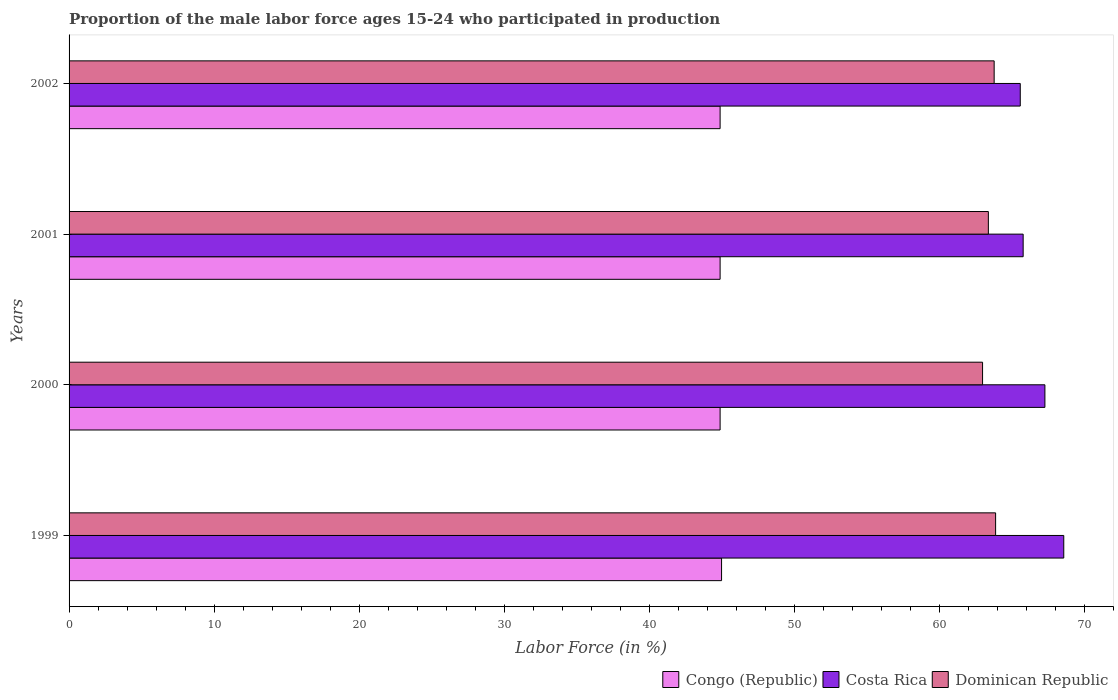How many different coloured bars are there?
Your response must be concise. 3. Are the number of bars per tick equal to the number of legend labels?
Offer a very short reply. Yes. Are the number of bars on each tick of the Y-axis equal?
Your answer should be very brief. Yes. How many bars are there on the 1st tick from the top?
Give a very brief answer. 3. What is the label of the 1st group of bars from the top?
Ensure brevity in your answer.  2002. Across all years, what is the maximum proportion of the male labor force who participated in production in Costa Rica?
Make the answer very short. 68.6. Across all years, what is the minimum proportion of the male labor force who participated in production in Dominican Republic?
Ensure brevity in your answer.  63. In which year was the proportion of the male labor force who participated in production in Costa Rica maximum?
Your answer should be very brief. 1999. What is the total proportion of the male labor force who participated in production in Dominican Republic in the graph?
Your answer should be compact. 254.1. What is the difference between the proportion of the male labor force who participated in production in Congo (Republic) in 1999 and that in 2000?
Your response must be concise. 0.1. What is the difference between the proportion of the male labor force who participated in production in Congo (Republic) in 1999 and the proportion of the male labor force who participated in production in Dominican Republic in 2002?
Ensure brevity in your answer.  -18.8. What is the average proportion of the male labor force who participated in production in Dominican Republic per year?
Provide a short and direct response. 63.53. In the year 2001, what is the difference between the proportion of the male labor force who participated in production in Costa Rica and proportion of the male labor force who participated in production in Dominican Republic?
Provide a succinct answer. 2.4. What is the ratio of the proportion of the male labor force who participated in production in Dominican Republic in 1999 to that in 2000?
Offer a terse response. 1.01. Is the proportion of the male labor force who participated in production in Congo (Republic) in 1999 less than that in 2002?
Offer a very short reply. No. What is the difference between the highest and the second highest proportion of the male labor force who participated in production in Dominican Republic?
Your response must be concise. 0.1. What is the difference between the highest and the lowest proportion of the male labor force who participated in production in Dominican Republic?
Give a very brief answer. 0.9. In how many years, is the proportion of the male labor force who participated in production in Dominican Republic greater than the average proportion of the male labor force who participated in production in Dominican Republic taken over all years?
Provide a succinct answer. 2. Is the sum of the proportion of the male labor force who participated in production in Dominican Republic in 2001 and 2002 greater than the maximum proportion of the male labor force who participated in production in Costa Rica across all years?
Provide a short and direct response. Yes. What does the 2nd bar from the bottom in 2001 represents?
Provide a short and direct response. Costa Rica. Is it the case that in every year, the sum of the proportion of the male labor force who participated in production in Dominican Republic and proportion of the male labor force who participated in production in Congo (Republic) is greater than the proportion of the male labor force who participated in production in Costa Rica?
Your answer should be compact. Yes. How many bars are there?
Offer a terse response. 12. Are the values on the major ticks of X-axis written in scientific E-notation?
Offer a terse response. No. Does the graph contain grids?
Your answer should be compact. No. Where does the legend appear in the graph?
Keep it short and to the point. Bottom right. How many legend labels are there?
Keep it short and to the point. 3. What is the title of the graph?
Ensure brevity in your answer.  Proportion of the male labor force ages 15-24 who participated in production. Does "Hong Kong" appear as one of the legend labels in the graph?
Provide a short and direct response. No. What is the Labor Force (in %) of Costa Rica in 1999?
Provide a short and direct response. 68.6. What is the Labor Force (in %) of Dominican Republic in 1999?
Provide a short and direct response. 63.9. What is the Labor Force (in %) of Congo (Republic) in 2000?
Provide a short and direct response. 44.9. What is the Labor Force (in %) of Costa Rica in 2000?
Your response must be concise. 67.3. What is the Labor Force (in %) of Congo (Republic) in 2001?
Provide a succinct answer. 44.9. What is the Labor Force (in %) of Costa Rica in 2001?
Ensure brevity in your answer.  65.8. What is the Labor Force (in %) of Dominican Republic in 2001?
Make the answer very short. 63.4. What is the Labor Force (in %) in Congo (Republic) in 2002?
Your response must be concise. 44.9. What is the Labor Force (in %) of Costa Rica in 2002?
Keep it short and to the point. 65.6. What is the Labor Force (in %) in Dominican Republic in 2002?
Provide a succinct answer. 63.8. Across all years, what is the maximum Labor Force (in %) of Costa Rica?
Give a very brief answer. 68.6. Across all years, what is the maximum Labor Force (in %) of Dominican Republic?
Make the answer very short. 63.9. Across all years, what is the minimum Labor Force (in %) in Congo (Republic)?
Keep it short and to the point. 44.9. Across all years, what is the minimum Labor Force (in %) of Costa Rica?
Make the answer very short. 65.6. Across all years, what is the minimum Labor Force (in %) in Dominican Republic?
Make the answer very short. 63. What is the total Labor Force (in %) of Congo (Republic) in the graph?
Your response must be concise. 179.7. What is the total Labor Force (in %) in Costa Rica in the graph?
Offer a very short reply. 267.3. What is the total Labor Force (in %) in Dominican Republic in the graph?
Provide a short and direct response. 254.1. What is the difference between the Labor Force (in %) of Congo (Republic) in 1999 and that in 2000?
Your answer should be compact. 0.1. What is the difference between the Labor Force (in %) in Dominican Republic in 1999 and that in 2000?
Keep it short and to the point. 0.9. What is the difference between the Labor Force (in %) of Dominican Republic in 1999 and that in 2001?
Offer a very short reply. 0.5. What is the difference between the Labor Force (in %) of Congo (Republic) in 2000 and that in 2001?
Provide a succinct answer. 0. What is the difference between the Labor Force (in %) in Costa Rica in 2000 and that in 2002?
Offer a very short reply. 1.7. What is the difference between the Labor Force (in %) in Dominican Republic in 2000 and that in 2002?
Offer a terse response. -0.8. What is the difference between the Labor Force (in %) of Costa Rica in 2001 and that in 2002?
Your answer should be very brief. 0.2. What is the difference between the Labor Force (in %) in Dominican Republic in 2001 and that in 2002?
Your answer should be very brief. -0.4. What is the difference between the Labor Force (in %) of Congo (Republic) in 1999 and the Labor Force (in %) of Costa Rica in 2000?
Provide a succinct answer. -22.3. What is the difference between the Labor Force (in %) of Costa Rica in 1999 and the Labor Force (in %) of Dominican Republic in 2000?
Offer a terse response. 5.6. What is the difference between the Labor Force (in %) in Congo (Republic) in 1999 and the Labor Force (in %) in Costa Rica in 2001?
Provide a short and direct response. -20.8. What is the difference between the Labor Force (in %) in Congo (Republic) in 1999 and the Labor Force (in %) in Dominican Republic in 2001?
Provide a short and direct response. -18.4. What is the difference between the Labor Force (in %) in Congo (Republic) in 1999 and the Labor Force (in %) in Costa Rica in 2002?
Make the answer very short. -20.6. What is the difference between the Labor Force (in %) in Congo (Republic) in 1999 and the Labor Force (in %) in Dominican Republic in 2002?
Provide a short and direct response. -18.8. What is the difference between the Labor Force (in %) of Congo (Republic) in 2000 and the Labor Force (in %) of Costa Rica in 2001?
Your answer should be very brief. -20.9. What is the difference between the Labor Force (in %) in Congo (Republic) in 2000 and the Labor Force (in %) in Dominican Republic in 2001?
Provide a short and direct response. -18.5. What is the difference between the Labor Force (in %) of Congo (Republic) in 2000 and the Labor Force (in %) of Costa Rica in 2002?
Your answer should be very brief. -20.7. What is the difference between the Labor Force (in %) in Congo (Republic) in 2000 and the Labor Force (in %) in Dominican Republic in 2002?
Offer a very short reply. -18.9. What is the difference between the Labor Force (in %) in Congo (Republic) in 2001 and the Labor Force (in %) in Costa Rica in 2002?
Make the answer very short. -20.7. What is the difference between the Labor Force (in %) of Congo (Republic) in 2001 and the Labor Force (in %) of Dominican Republic in 2002?
Offer a very short reply. -18.9. What is the difference between the Labor Force (in %) in Costa Rica in 2001 and the Labor Force (in %) in Dominican Republic in 2002?
Make the answer very short. 2. What is the average Labor Force (in %) of Congo (Republic) per year?
Ensure brevity in your answer.  44.92. What is the average Labor Force (in %) in Costa Rica per year?
Your answer should be compact. 66.83. What is the average Labor Force (in %) in Dominican Republic per year?
Your answer should be compact. 63.52. In the year 1999, what is the difference between the Labor Force (in %) in Congo (Republic) and Labor Force (in %) in Costa Rica?
Your answer should be compact. -23.6. In the year 1999, what is the difference between the Labor Force (in %) of Congo (Republic) and Labor Force (in %) of Dominican Republic?
Your answer should be very brief. -18.9. In the year 1999, what is the difference between the Labor Force (in %) in Costa Rica and Labor Force (in %) in Dominican Republic?
Your response must be concise. 4.7. In the year 2000, what is the difference between the Labor Force (in %) in Congo (Republic) and Labor Force (in %) in Costa Rica?
Your response must be concise. -22.4. In the year 2000, what is the difference between the Labor Force (in %) of Congo (Republic) and Labor Force (in %) of Dominican Republic?
Ensure brevity in your answer.  -18.1. In the year 2001, what is the difference between the Labor Force (in %) in Congo (Republic) and Labor Force (in %) in Costa Rica?
Make the answer very short. -20.9. In the year 2001, what is the difference between the Labor Force (in %) in Congo (Republic) and Labor Force (in %) in Dominican Republic?
Your response must be concise. -18.5. In the year 2002, what is the difference between the Labor Force (in %) in Congo (Republic) and Labor Force (in %) in Costa Rica?
Your answer should be very brief. -20.7. In the year 2002, what is the difference between the Labor Force (in %) of Congo (Republic) and Labor Force (in %) of Dominican Republic?
Give a very brief answer. -18.9. What is the ratio of the Labor Force (in %) of Costa Rica in 1999 to that in 2000?
Your response must be concise. 1.02. What is the ratio of the Labor Force (in %) in Dominican Republic in 1999 to that in 2000?
Provide a succinct answer. 1.01. What is the ratio of the Labor Force (in %) in Costa Rica in 1999 to that in 2001?
Offer a very short reply. 1.04. What is the ratio of the Labor Force (in %) in Dominican Republic in 1999 to that in 2001?
Make the answer very short. 1.01. What is the ratio of the Labor Force (in %) of Costa Rica in 1999 to that in 2002?
Keep it short and to the point. 1.05. What is the ratio of the Labor Force (in %) of Dominican Republic in 1999 to that in 2002?
Provide a short and direct response. 1. What is the ratio of the Labor Force (in %) of Congo (Republic) in 2000 to that in 2001?
Give a very brief answer. 1. What is the ratio of the Labor Force (in %) of Costa Rica in 2000 to that in 2001?
Offer a very short reply. 1.02. What is the ratio of the Labor Force (in %) in Dominican Republic in 2000 to that in 2001?
Your answer should be very brief. 0.99. What is the ratio of the Labor Force (in %) in Congo (Republic) in 2000 to that in 2002?
Your answer should be compact. 1. What is the ratio of the Labor Force (in %) in Costa Rica in 2000 to that in 2002?
Provide a short and direct response. 1.03. What is the ratio of the Labor Force (in %) in Dominican Republic in 2000 to that in 2002?
Your answer should be very brief. 0.99. What is the ratio of the Labor Force (in %) in Dominican Republic in 2001 to that in 2002?
Your answer should be very brief. 0.99. What is the difference between the highest and the lowest Labor Force (in %) of Costa Rica?
Offer a very short reply. 3. What is the difference between the highest and the lowest Labor Force (in %) of Dominican Republic?
Your response must be concise. 0.9. 